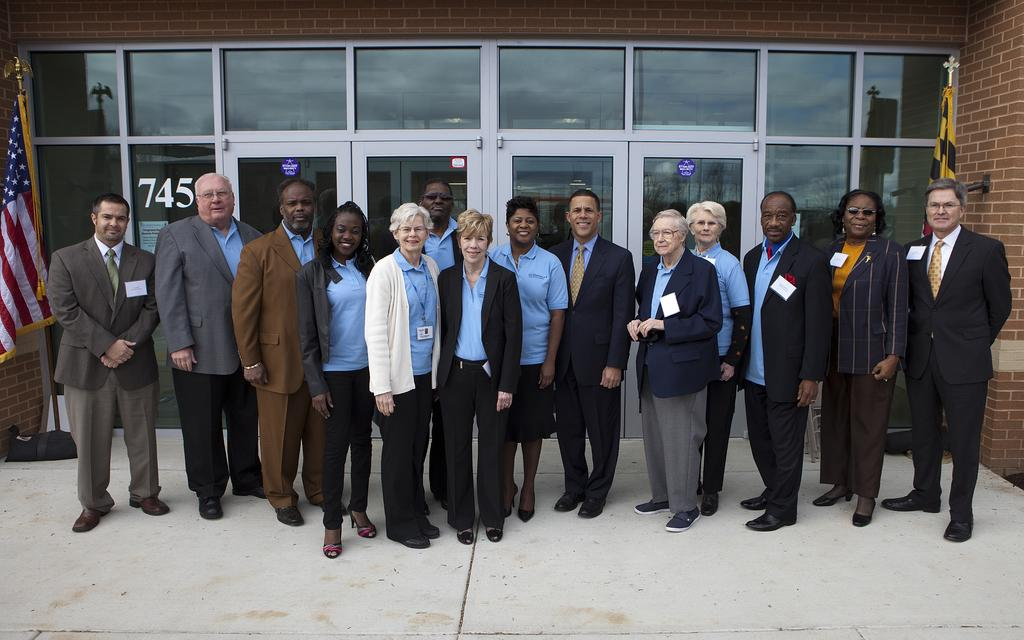What can be seen in the image? There are people standing in the image. Where are the people standing? The people are standing on the floor. What else is visible in the image besides the people? There are flags visible in the image. What can be seen in the background of the image? There is a building in the background of the image. How much sugar is present in the image? There is no sugar present in the image. What type of range can be seen in the image? There is no range present in the image. 